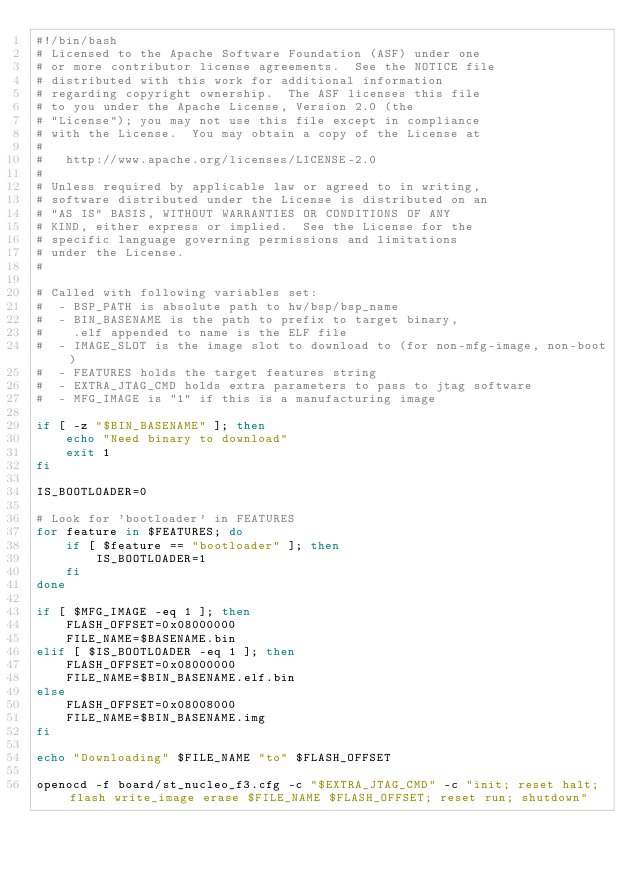Convert code to text. <code><loc_0><loc_0><loc_500><loc_500><_Bash_>#!/bin/bash
# Licensed to the Apache Software Foundation (ASF) under one
# or more contributor license agreements.  See the NOTICE file
# distributed with this work for additional information
# regarding copyright ownership.  The ASF licenses this file
# to you under the Apache License, Version 2.0 (the
# "License"); you may not use this file except in compliance
# with the License.  You may obtain a copy of the License at
# 
#   http://www.apache.org/licenses/LICENSE-2.0
# 
# Unless required by applicable law or agreed to in writing,
# software distributed under the License is distributed on an
# "AS IS" BASIS, WITHOUT WARRANTIES OR CONDITIONS OF ANY
# KIND, either express or implied.  See the License for the
# specific language governing permissions and limitations
# under the License.
#

# Called with following variables set:
#  - BSP_PATH is absolute path to hw/bsp/bsp_name
#  - BIN_BASENAME is the path to prefix to target binary,
#    .elf appended to name is the ELF file
#  - IMAGE_SLOT is the image slot to download to (for non-mfg-image, non-boot)
#  - FEATURES holds the target features string
#  - EXTRA_JTAG_CMD holds extra parameters to pass to jtag software
#  - MFG_IMAGE is "1" if this is a manufacturing image

if [ -z "$BIN_BASENAME" ]; then
    echo "Need binary to download"
    exit 1
fi

IS_BOOTLOADER=0

# Look for 'bootloader' in FEATURES
for feature in $FEATURES; do
    if [ $feature == "bootloader" ]; then
        IS_BOOTLOADER=1
    fi
done

if [ $MFG_IMAGE -eq 1 ]; then
    FLASH_OFFSET=0x08000000
    FILE_NAME=$BASENAME.bin
elif [ $IS_BOOTLOADER -eq 1 ]; then
    FLASH_OFFSET=0x08000000
    FILE_NAME=$BIN_BASENAME.elf.bin
else
    FLASH_OFFSET=0x08008000
    FILE_NAME=$BIN_BASENAME.img
fi

echo "Downloading" $FILE_NAME "to" $FLASH_OFFSET

openocd -f board/st_nucleo_f3.cfg -c "$EXTRA_JTAG_CMD" -c "init; reset halt; flash write_image erase $FILE_NAME $FLASH_OFFSET; reset run; shutdown"

</code> 